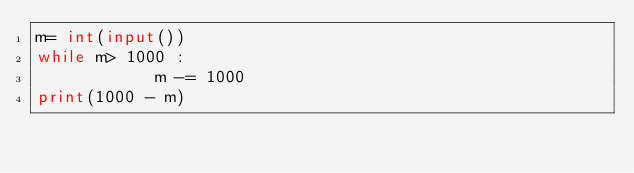<code> <loc_0><loc_0><loc_500><loc_500><_Python_>m= int(input())
while m> 1000 :
            m -= 1000
print(1000 - m)
</code> 